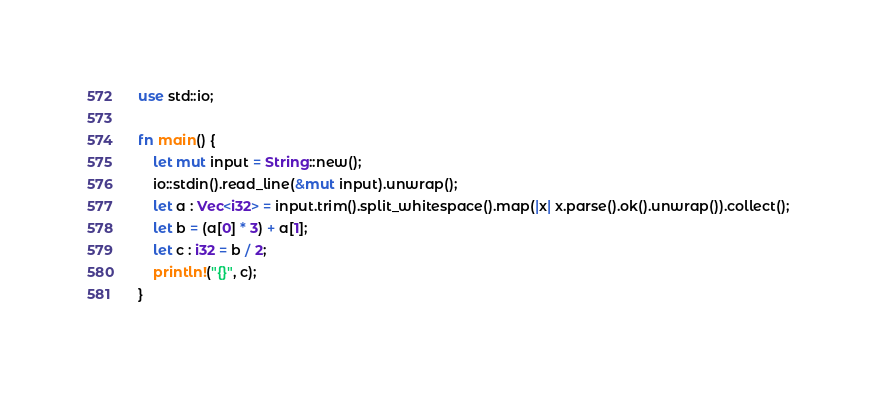Convert code to text. <code><loc_0><loc_0><loc_500><loc_500><_Rust_>use std::io;

fn main() {
    let mut input = String::new();
    io::stdin().read_line(&mut input).unwrap();
    let a : Vec<i32> = input.trim().split_whitespace().map(|x| x.parse().ok().unwrap()).collect();
    let b = (a[0] * 3) + a[1];
    let c : i32 = b / 2;
    println!("{}", c);
}

</code> 